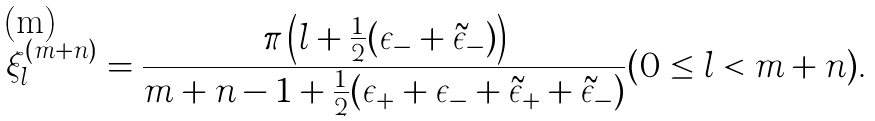<formula> <loc_0><loc_0><loc_500><loc_500>\xi ^ { ( m + n ) } _ { l } = \frac { \pi \left ( { l } + \frac { 1 } { 2 } ( \epsilon _ { - } + \tilde { \epsilon } _ { - } ) \right ) } { m + n - 1 + \frac { 1 } { 2 } ( \epsilon _ { + } + \epsilon _ { - } + \tilde { \epsilon } _ { + } + \tilde { \epsilon } _ { - } ) } ( 0 \leq { l } < m + n ) .</formula> 